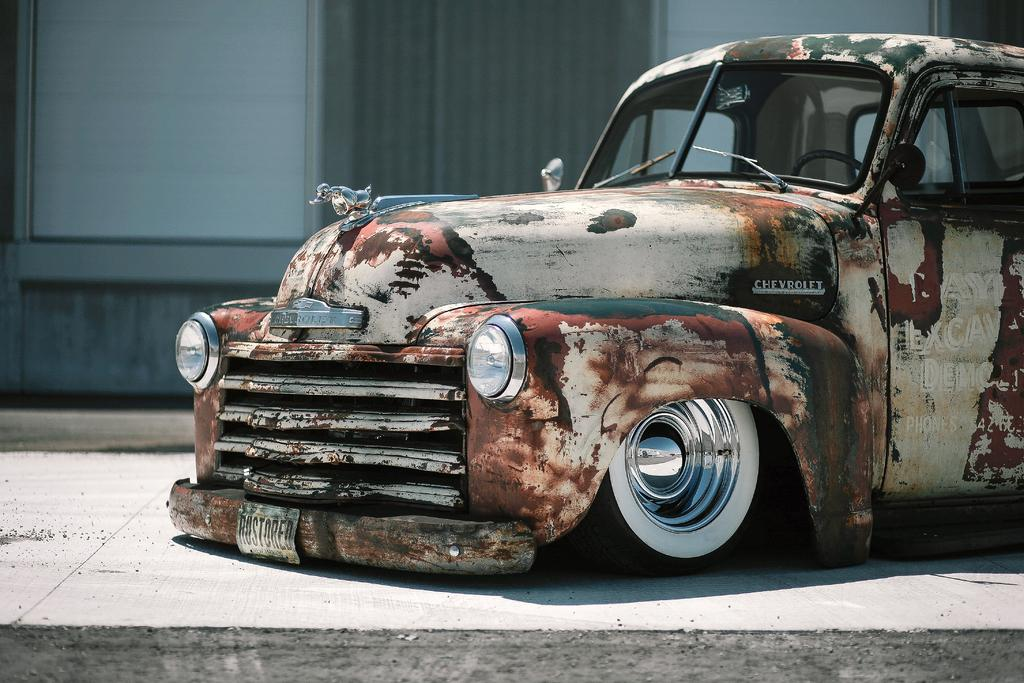What is partially visible on the right side of the image? There is a car truncated towards the right of the image. What else is partially visible in the image? There is ground truncated in the image. What can be seen in the background of the image? There is a wall truncated in the background of the image. How many pests can be seen crawling on the car in the image? There are no pests visible in the image; it only shows a car, ground, and a wall. Can you describe the kicking motion of the person in the image? There is no person present in the image, and therefore no kicking motion can be observed. 